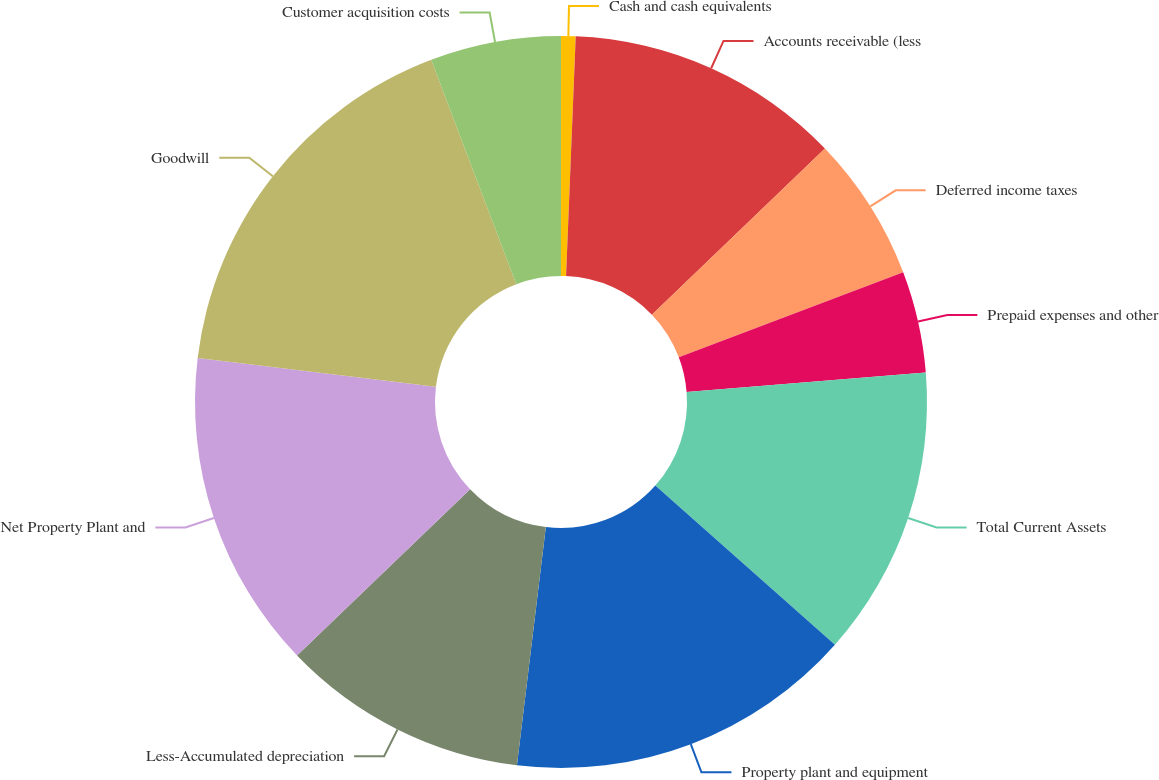Convert chart. <chart><loc_0><loc_0><loc_500><loc_500><pie_chart><fcel>Cash and cash equivalents<fcel>Accounts receivable (less<fcel>Deferred income taxes<fcel>Prepaid expenses and other<fcel>Total Current Assets<fcel>Property plant and equipment<fcel>Less-Accumulated depreciation<fcel>Net Property Plant and<fcel>Goodwill<fcel>Customer acquisition costs<nl><fcel>0.64%<fcel>12.18%<fcel>6.41%<fcel>4.49%<fcel>12.82%<fcel>15.38%<fcel>10.9%<fcel>14.1%<fcel>17.31%<fcel>5.77%<nl></chart> 